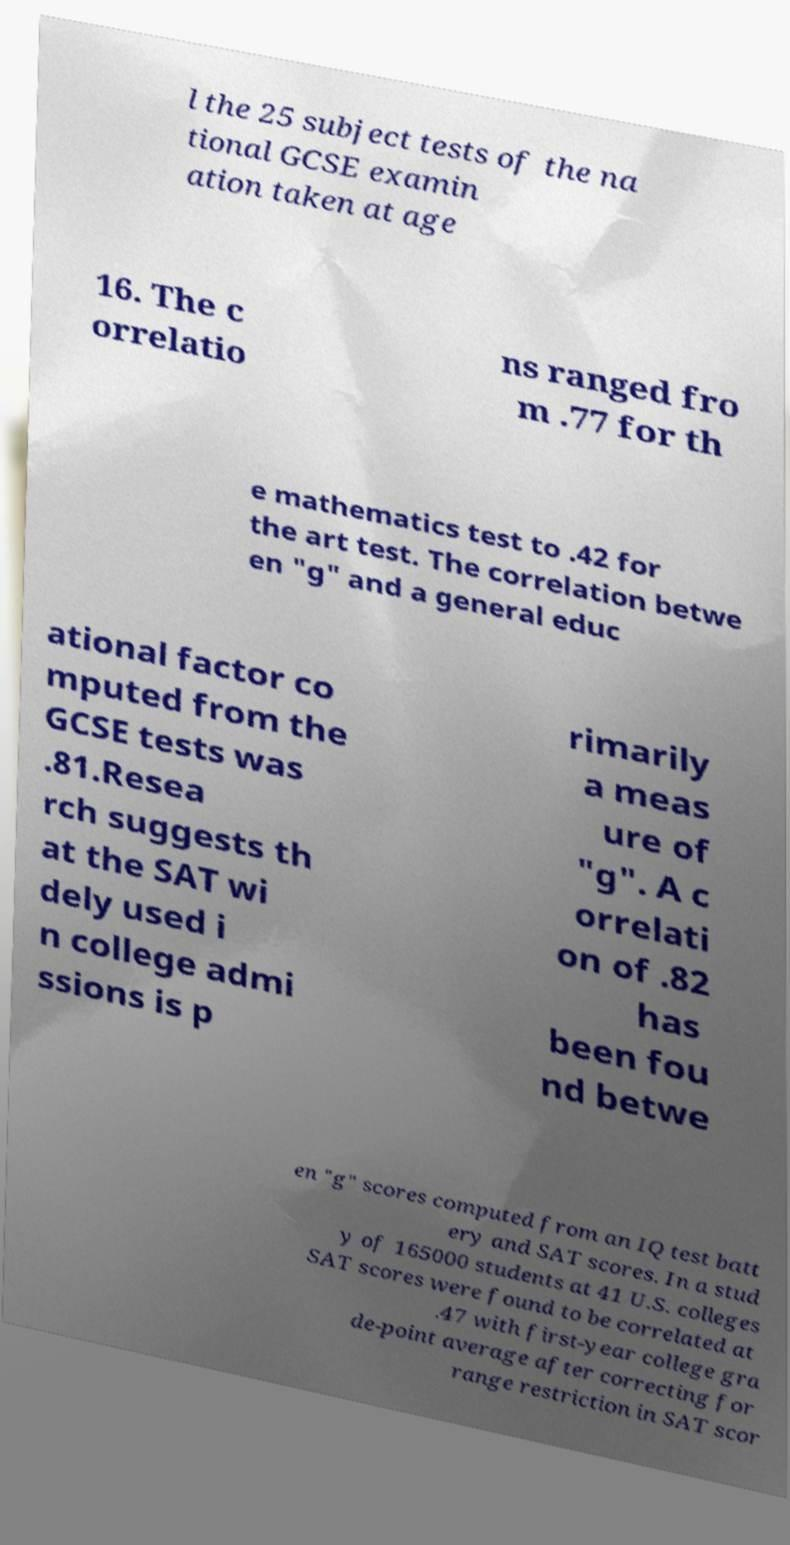Could you assist in decoding the text presented in this image and type it out clearly? l the 25 subject tests of the na tional GCSE examin ation taken at age 16. The c orrelatio ns ranged fro m .77 for th e mathematics test to .42 for the art test. The correlation betwe en "g" and a general educ ational factor co mputed from the GCSE tests was .81.Resea rch suggests th at the SAT wi dely used i n college admi ssions is p rimarily a meas ure of "g". A c orrelati on of .82 has been fou nd betwe en "g" scores computed from an IQ test batt ery and SAT scores. In a stud y of 165000 students at 41 U.S. colleges SAT scores were found to be correlated at .47 with first-year college gra de-point average after correcting for range restriction in SAT scor 